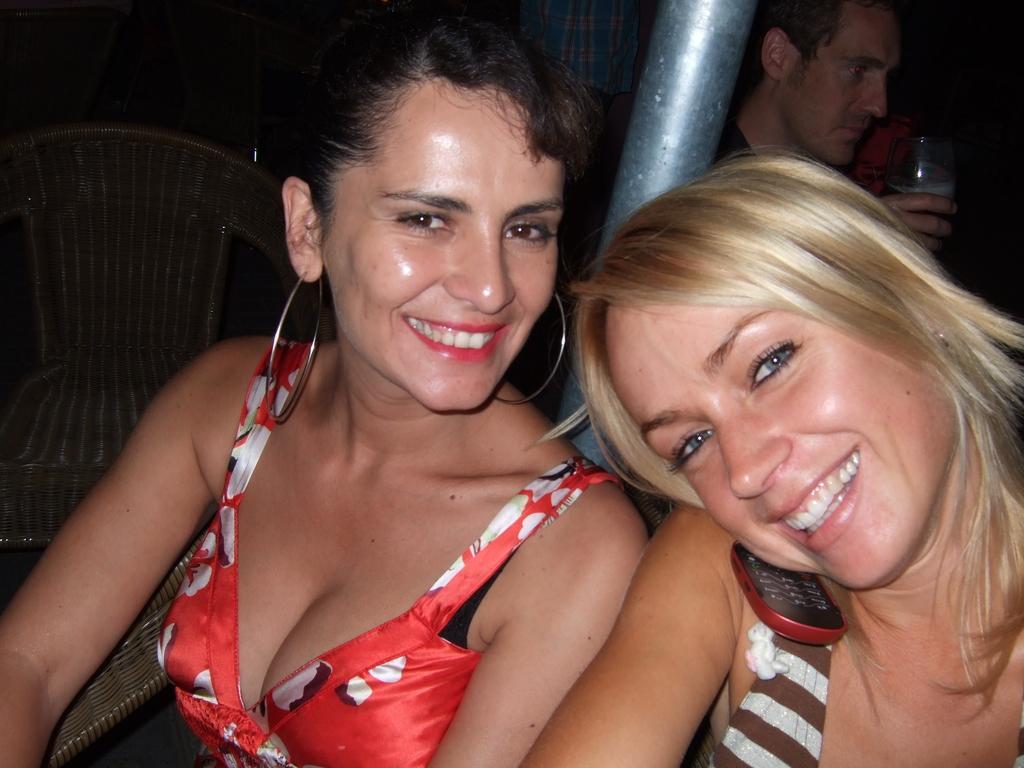Describe this image in one or two sentences. In this picture there are two girls in the center of the image, there is a pole behind them and there is a boy and a chair in the background area of the image. 